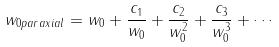Convert formula to latex. <formula><loc_0><loc_0><loc_500><loc_500>w _ { 0 p a r a x i a l } = w _ { 0 } + \frac { c _ { 1 } } { w _ { 0 } } + \frac { c _ { 2 } } { w _ { 0 } ^ { 2 } } + \frac { c _ { 3 } } { w _ { 0 } ^ { 3 } } + \cdots</formula> 